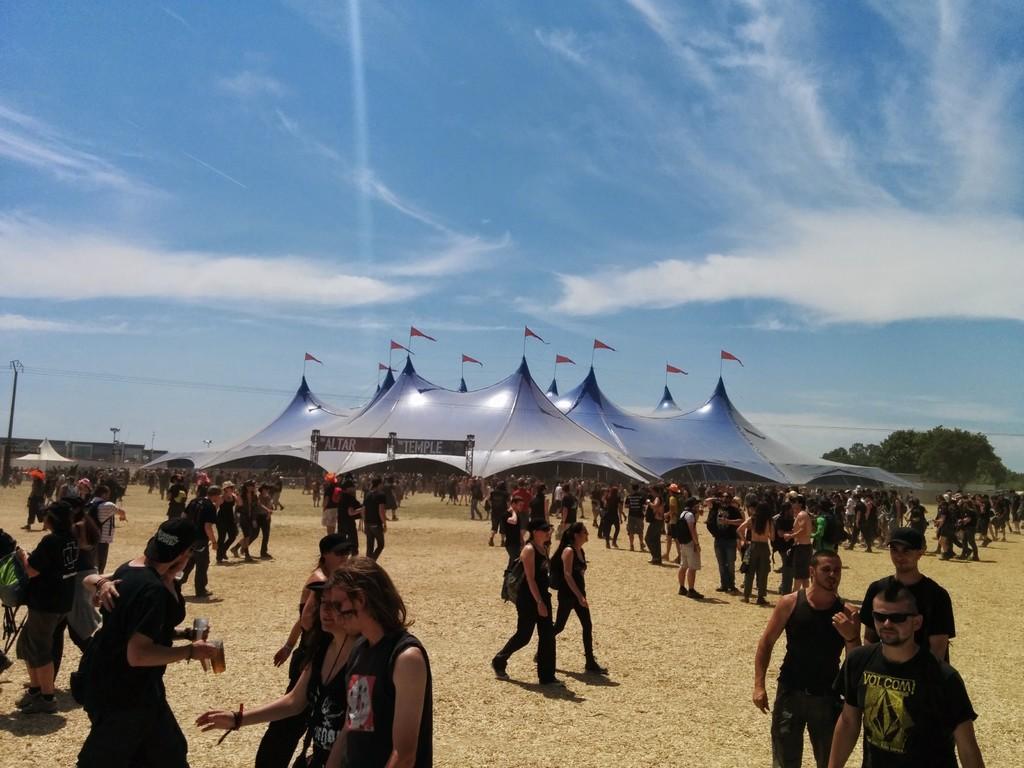Describe this image in one or two sentences. To the bottom of the image there are many people standing on the ground. Behind them in the background there is a blue tent with red flags. And also there are many trees. And to the top of the image there is a sky with clouds. 